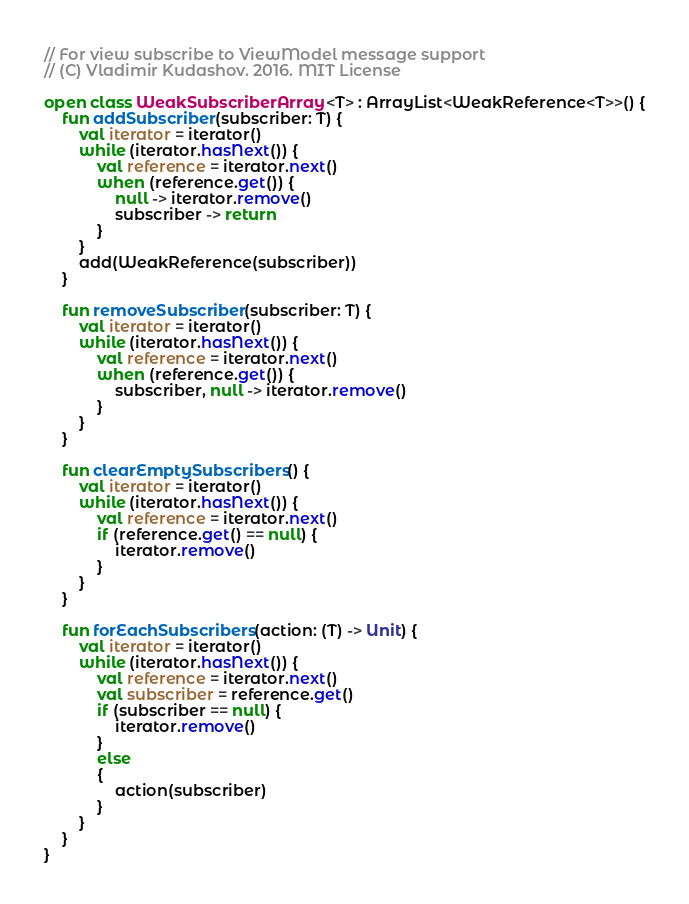Convert code to text. <code><loc_0><loc_0><loc_500><loc_500><_Kotlin_>// For view subscribe to ViewModel message support
// (C) Vladimir Kudashov. 2016. MIT License

open class WeakSubscriberArray <T> : ArrayList<WeakReference<T>>() {
    fun addSubscriber(subscriber: T) {
        val iterator = iterator()
        while (iterator.hasNext()) {
            val reference = iterator.next()
            when (reference.get()) {
                null -> iterator.remove()
                subscriber -> return
            }
        }
        add(WeakReference(subscriber))
    }

    fun removeSubscriber(subscriber: T) {
        val iterator = iterator()
        while (iterator.hasNext()) {
            val reference = iterator.next()
            when (reference.get()) {
                subscriber, null -> iterator.remove()
            }
        }
    }

    fun clearEmptySubscribers() {
        val iterator = iterator()
        while (iterator.hasNext()) {
            val reference = iterator.next()
            if (reference.get() == null) {
                iterator.remove()
            }
        }
    }

    fun forEachSubscribers(action: (T) -> Unit) {
        val iterator = iterator()
        while (iterator.hasNext()) {
            val reference = iterator.next()
            val subscriber = reference.get()
            if (subscriber == null) {
                iterator.remove()
            }
            else
            {
                action(subscriber)
            }
        }
    }
}</code> 